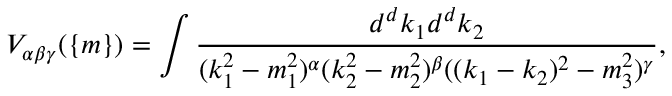<formula> <loc_0><loc_0><loc_500><loc_500>V _ { \alpha \beta \gamma } ( \{ m \} ) = \int \frac { d ^ { d } k _ { 1 } d ^ { d } k _ { 2 } } { ( k _ { 1 } ^ { 2 } - m _ { 1 } ^ { 2 } ) ^ { \alpha } ( k _ { 2 } ^ { 2 } - m _ { 2 } ^ { 2 } ) ^ { \beta } ( ( k _ { 1 } - k _ { 2 } ) ^ { 2 } - m _ { 3 } ^ { 2 } ) ^ { \gamma } } ,</formula> 